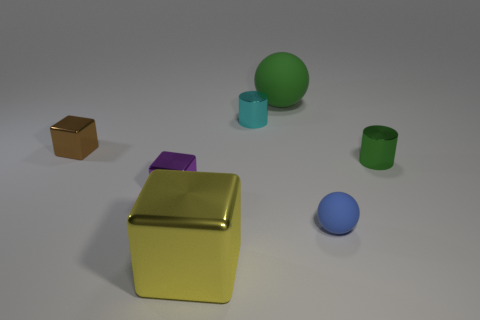Add 2 cubes. How many objects exist? 9 Subtract all spheres. How many objects are left? 5 Add 1 small purple metal blocks. How many small purple metal blocks exist? 2 Subtract 1 green cylinders. How many objects are left? 6 Subtract all blue metallic cylinders. Subtract all brown metal things. How many objects are left? 6 Add 7 small green cylinders. How many small green cylinders are left? 8 